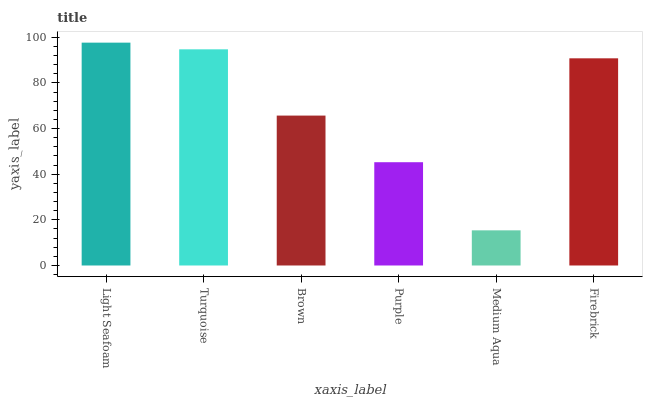Is Medium Aqua the minimum?
Answer yes or no. Yes. Is Light Seafoam the maximum?
Answer yes or no. Yes. Is Turquoise the minimum?
Answer yes or no. No. Is Turquoise the maximum?
Answer yes or no. No. Is Light Seafoam greater than Turquoise?
Answer yes or no. Yes. Is Turquoise less than Light Seafoam?
Answer yes or no. Yes. Is Turquoise greater than Light Seafoam?
Answer yes or no. No. Is Light Seafoam less than Turquoise?
Answer yes or no. No. Is Firebrick the high median?
Answer yes or no. Yes. Is Brown the low median?
Answer yes or no. Yes. Is Medium Aqua the high median?
Answer yes or no. No. Is Medium Aqua the low median?
Answer yes or no. No. 